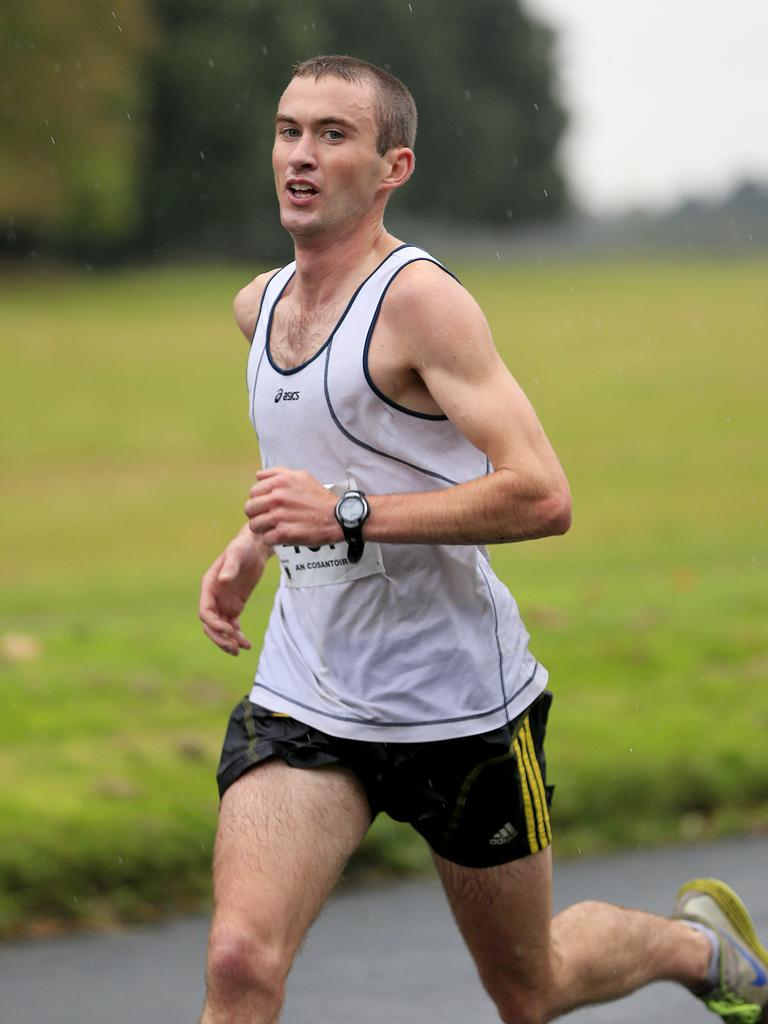<image>
Relay a brief, clear account of the picture shown. a man running with Adidas shorts on his person 